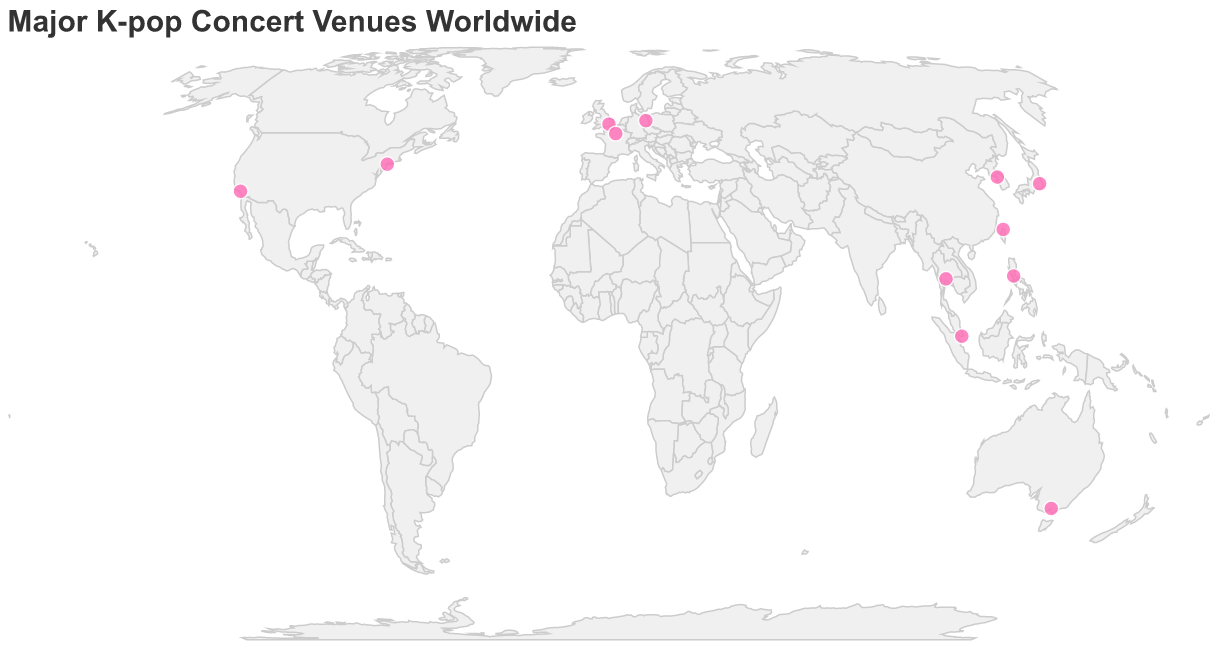Which city has the venue called "The O2 Arena"? The tooltip on the plot shows that the venue "The O2 Arena" is located in London.
Answer: London How many venues are located in the USA according to the map? By counting the data points labeled with "USA" on the tooltips, we find that there are two venues: Madison Square Garden in New York and Staples Center in Los Angeles.
Answer: 2 Which venue is situated closest to the equator? By checking the latitude values on the map, the venue closest to the equator is the Singapore Indoor Stadium in Singapore, with a latitude of 1.3017.
Answer: Singapore Indoor Stadium What is the most southern venue according to the plot? By examining the latitude values on the map, the most southern venue is the Rod Laver Arena in Melbourne, Australia, with a latitude of -37.8221.
Answer: Rod Laver Arena Which venue is further east, Mall of Asia Arena or Taipei Arena? By comparing the longitude values on the map, the Mall of Asia Arena has a longitude of 120.9837 and the Taipei Arena has a longitude of 121.5500. Since 121.5500 is further east than 120.9837, Taipei Arena is further east.
Answer: Taipei Arena Which country has the highest number of major K-pop concert venues according to the data? By counting the occurrences of each country on the map, the USA has the highest number of venues, with two: Madison Square Garden and Staples Center.
Answer: USA Which city is home to the Jamsil Olympic Stadium? The tooltip reveals that the Jamsil Olympic Stadium is located in Seoul, South Korea.
Answer: Seoul How many major K-pop concert venues are located in Europe according to the map? By counting the venues in Europe: The O2 Arena in London, AccorHotels Arena in Paris, and Mercedes-Benz Arena in Berlin. This gives a total of 3 venues.
Answer: 3 